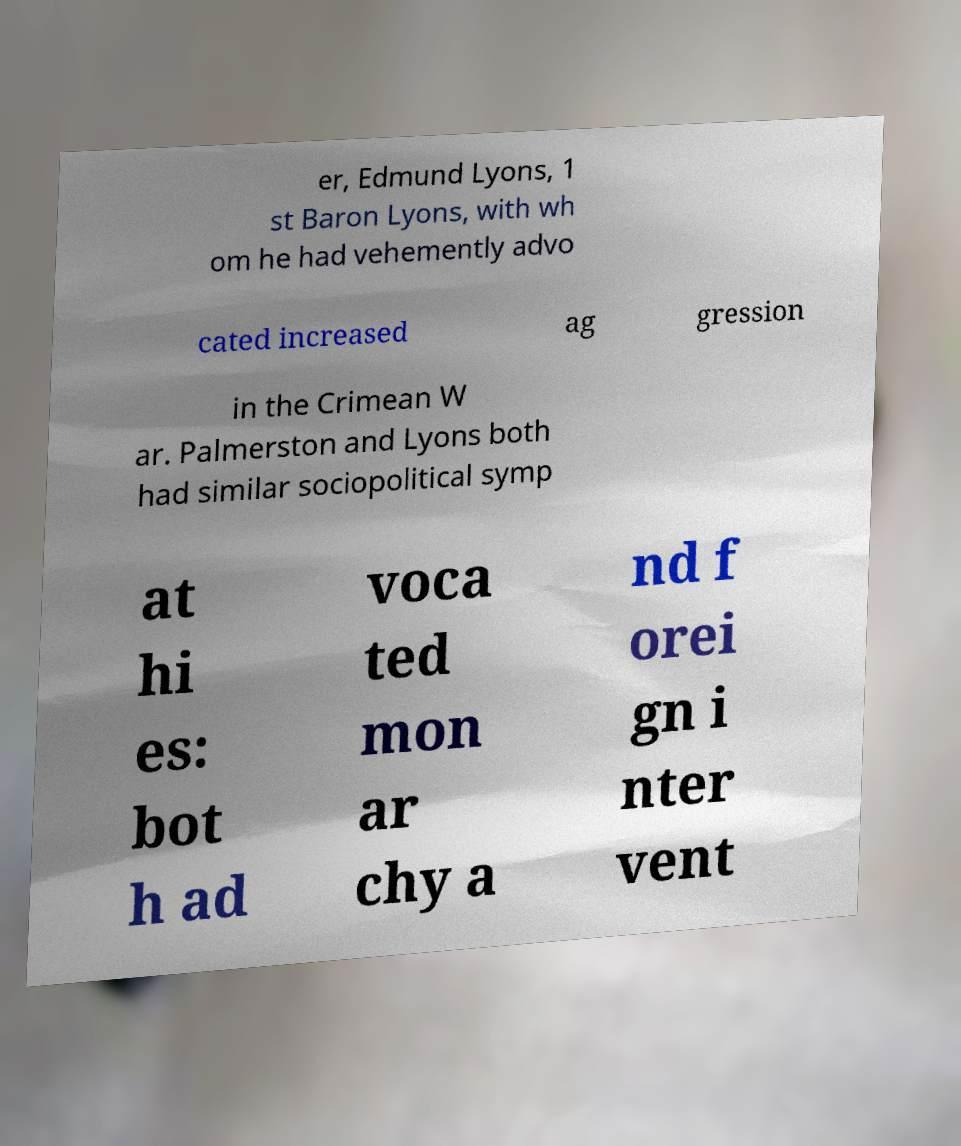Please identify and transcribe the text found in this image. er, Edmund Lyons, 1 st Baron Lyons, with wh om he had vehemently advo cated increased ag gression in the Crimean W ar. Palmerston and Lyons both had similar sociopolitical symp at hi es: bot h ad voca ted mon ar chy a nd f orei gn i nter vent 